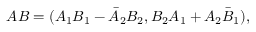<formula> <loc_0><loc_0><loc_500><loc_500>A B = ( A _ { 1 } B _ { 1 } - \bar { A } _ { 2 } B _ { 2 } , B _ { 2 } A _ { 1 } + A _ { 2 } \bar { B } _ { 1 } ) ,</formula> 